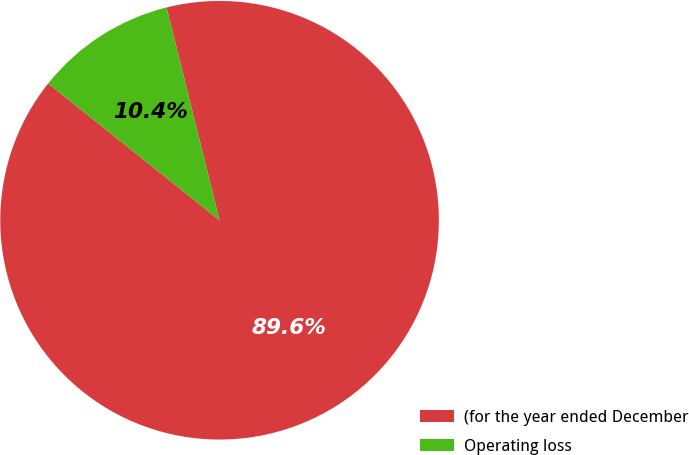Convert chart. <chart><loc_0><loc_0><loc_500><loc_500><pie_chart><fcel>(for the year ended December<fcel>Operating loss<nl><fcel>89.61%<fcel>10.39%<nl></chart> 